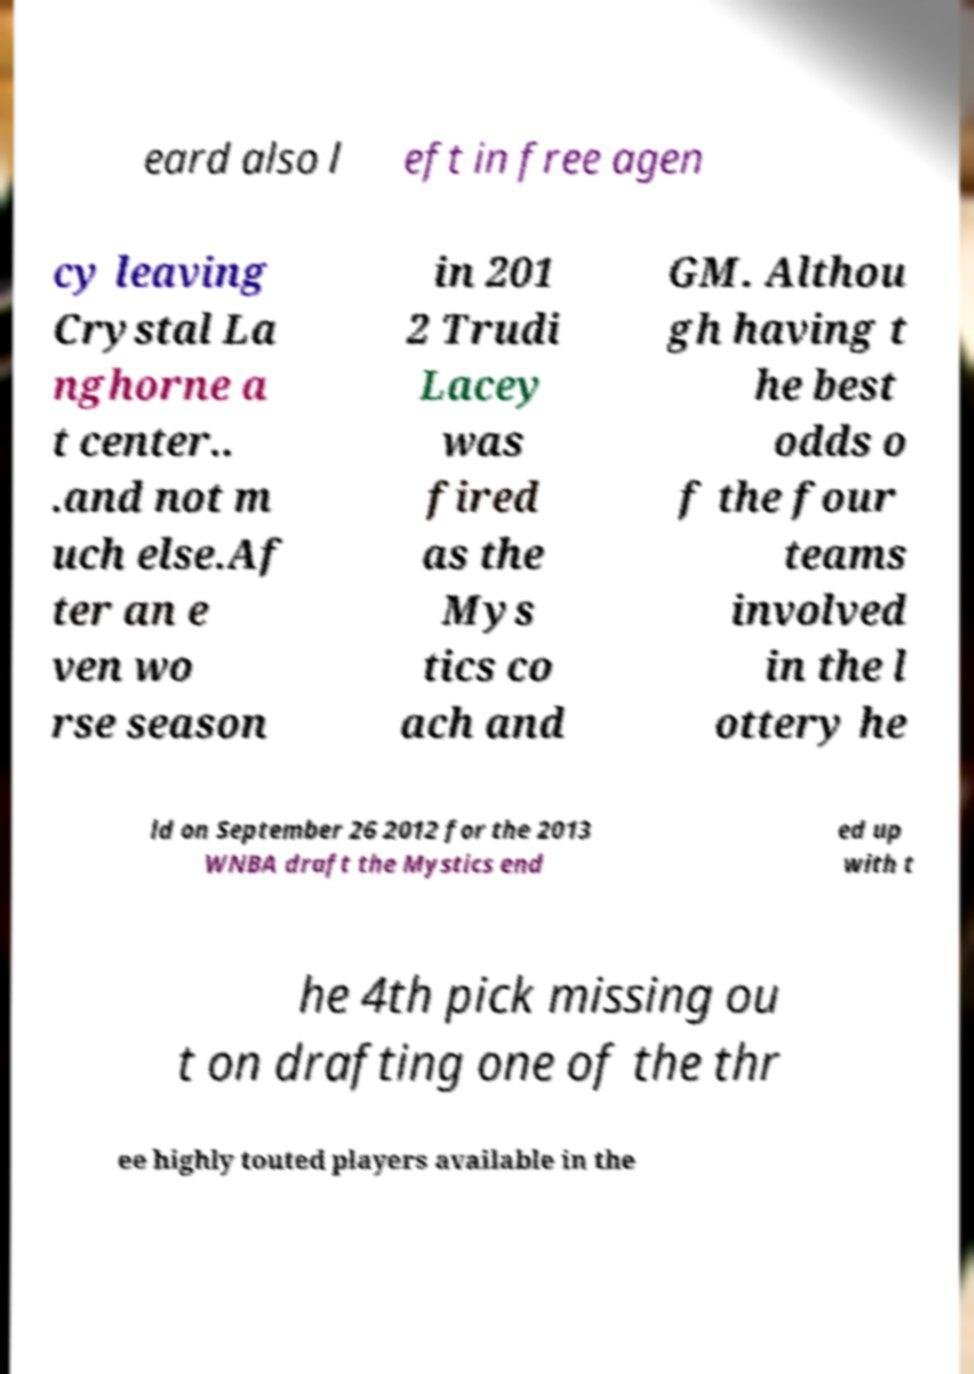What messages or text are displayed in this image? I need them in a readable, typed format. eard also l eft in free agen cy leaving Crystal La nghorne a t center.. .and not m uch else.Af ter an e ven wo rse season in 201 2 Trudi Lacey was fired as the Mys tics co ach and GM. Althou gh having t he best odds o f the four teams involved in the l ottery he ld on September 26 2012 for the 2013 WNBA draft the Mystics end ed up with t he 4th pick missing ou t on drafting one of the thr ee highly touted players available in the 